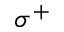Convert formula to latex. <formula><loc_0><loc_0><loc_500><loc_500>\sigma ^ { + }</formula> 